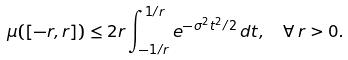Convert formula to latex. <formula><loc_0><loc_0><loc_500><loc_500>\mu ( [ - r , r ] ) & \leq 2 r \int _ { - 1 / r } ^ { 1 / r } e ^ { - \sigma ^ { 2 } t ^ { 2 } / 2 } \, d t , \quad \forall \, r > 0 . \quad</formula> 